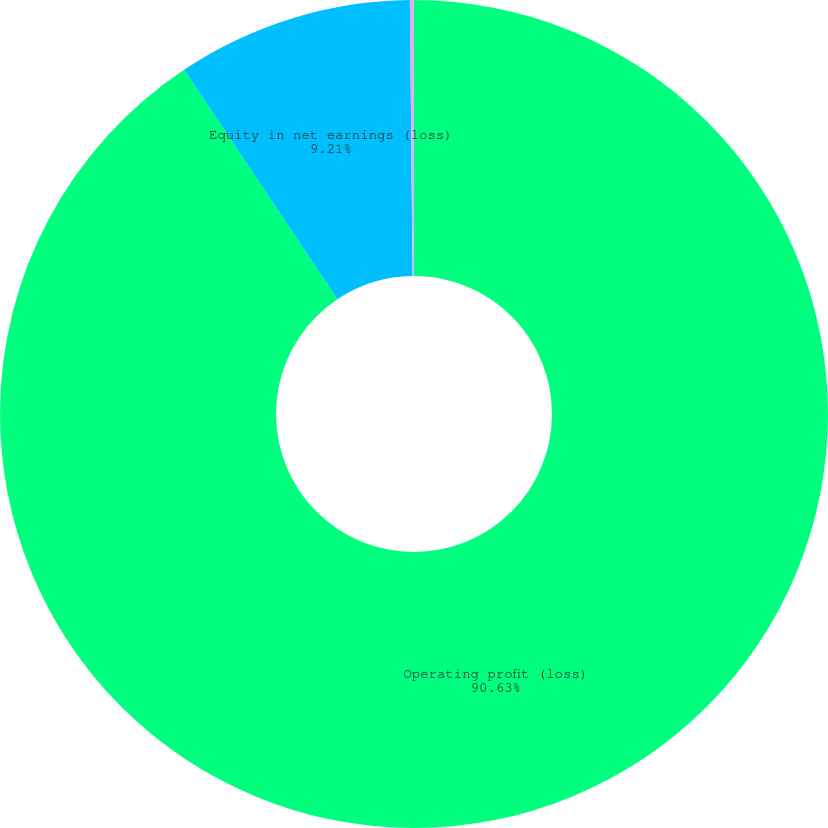Convert chart to OTSL. <chart><loc_0><loc_0><loc_500><loc_500><pie_chart><fcel>Operating profit (loss)<fcel>Equity in net earnings (loss)<fcel>Depreciation and amortization<nl><fcel>90.63%<fcel>9.21%<fcel>0.16%<nl></chart> 